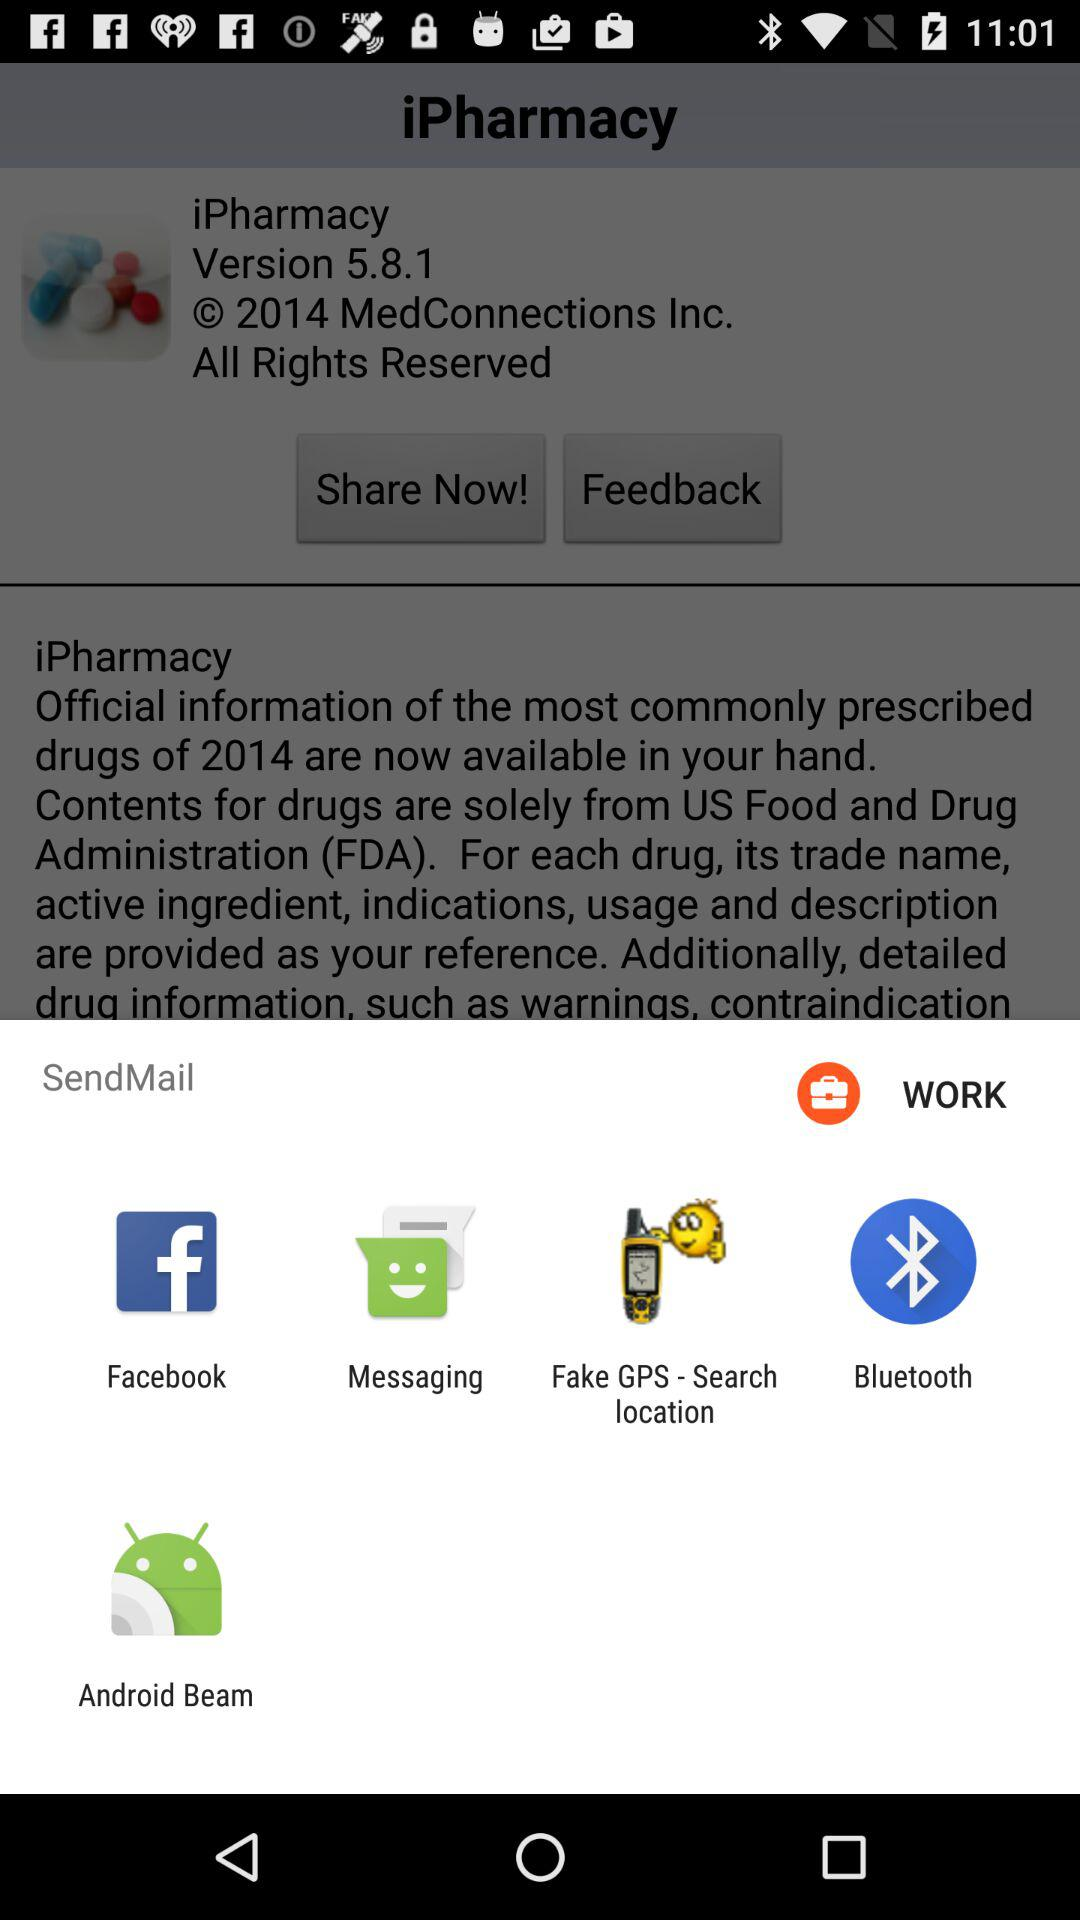What are the different applications through which we can send mail? The different applications are "Facebook", "Messaging", "Fake GPS - Search location", "Bluetooth" and "Android Beam". 